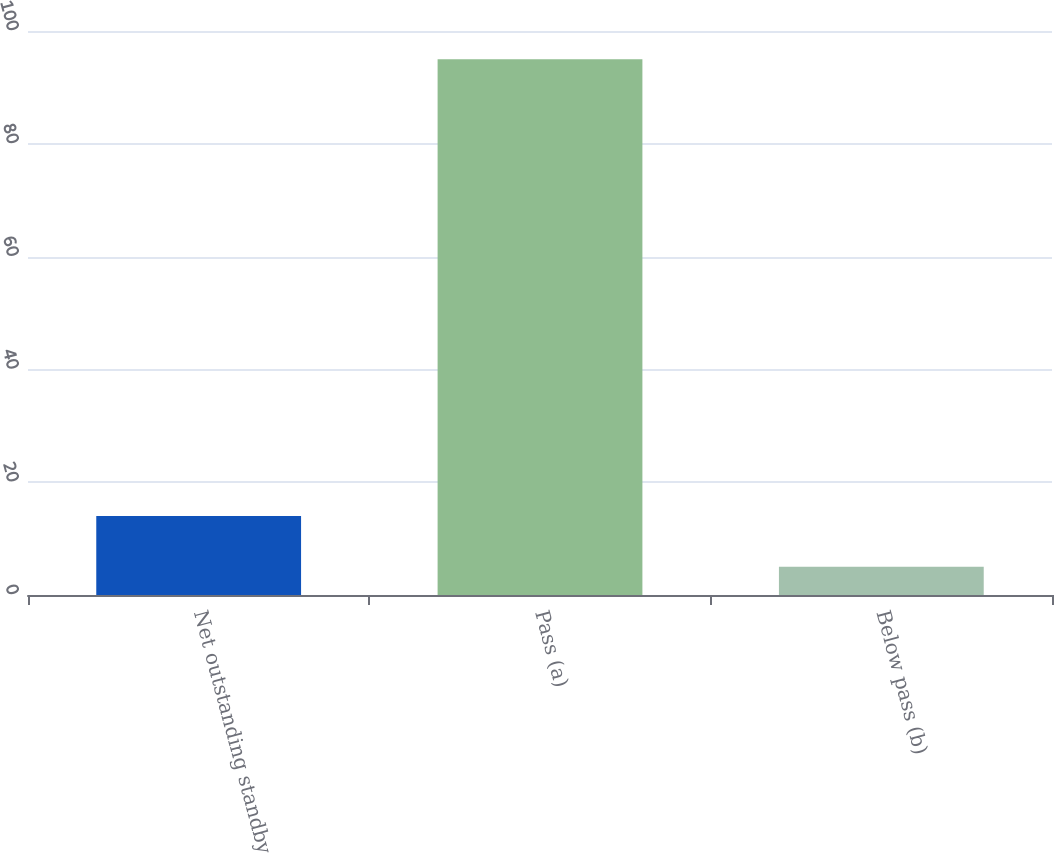Convert chart. <chart><loc_0><loc_0><loc_500><loc_500><bar_chart><fcel>Net outstanding standby<fcel>Pass (a)<fcel>Below pass (b)<nl><fcel>14<fcel>95<fcel>5<nl></chart> 